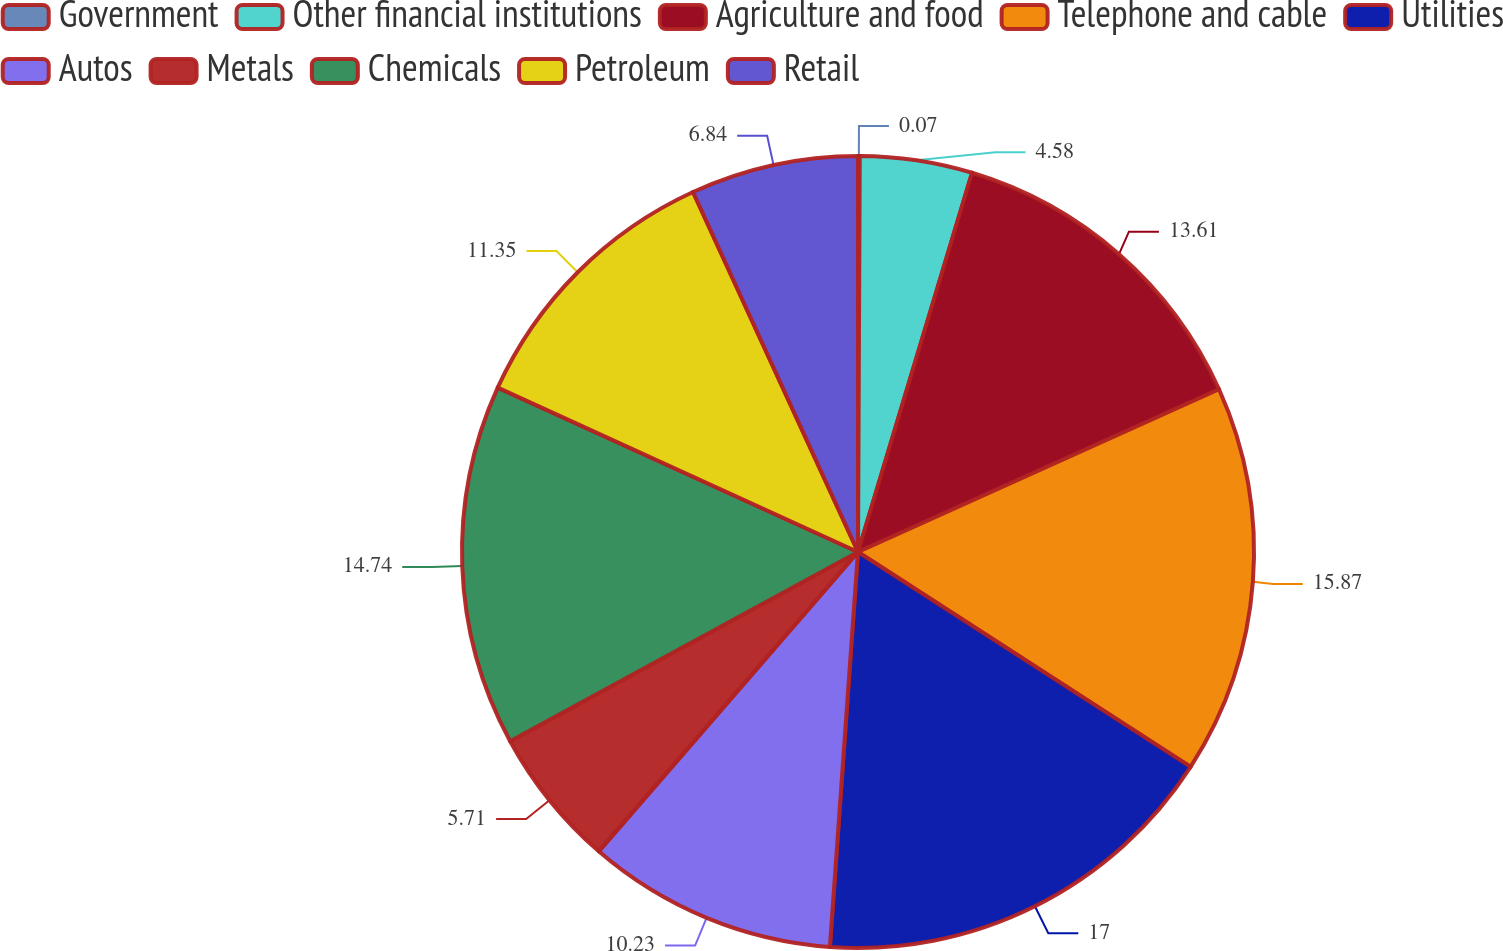<chart> <loc_0><loc_0><loc_500><loc_500><pie_chart><fcel>Government<fcel>Other financial institutions<fcel>Agriculture and food<fcel>Telephone and cable<fcel>Utilities<fcel>Autos<fcel>Metals<fcel>Chemicals<fcel>Petroleum<fcel>Retail<nl><fcel>0.07%<fcel>4.58%<fcel>13.61%<fcel>15.87%<fcel>17.0%<fcel>10.23%<fcel>5.71%<fcel>14.74%<fcel>11.35%<fcel>6.84%<nl></chart> 